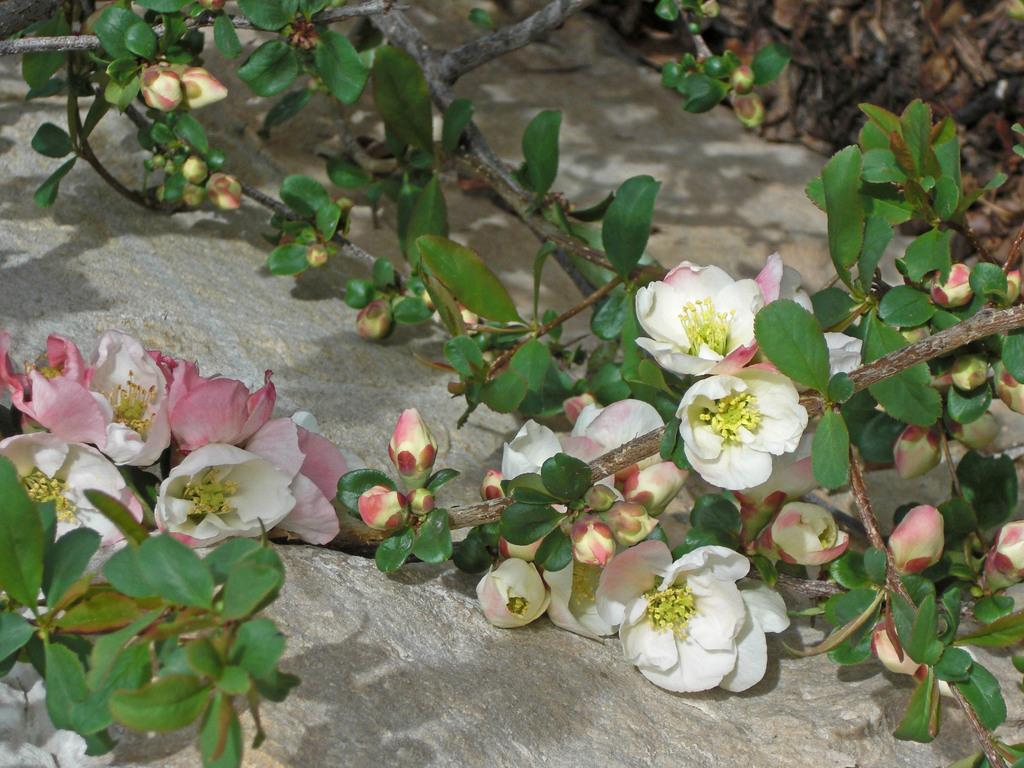What is located at the bottom of the image? There is a rock at the bottom of the image. What is growing on the rock? There are stems on the rock. What can be found on the stems? The stems have flowers, buds, and leaves. What colors are the flowers? The flowers are in white and pink colors. How does the rock give its approval in the image? The rock does not give approval in the image, as it is an inanimate object. 